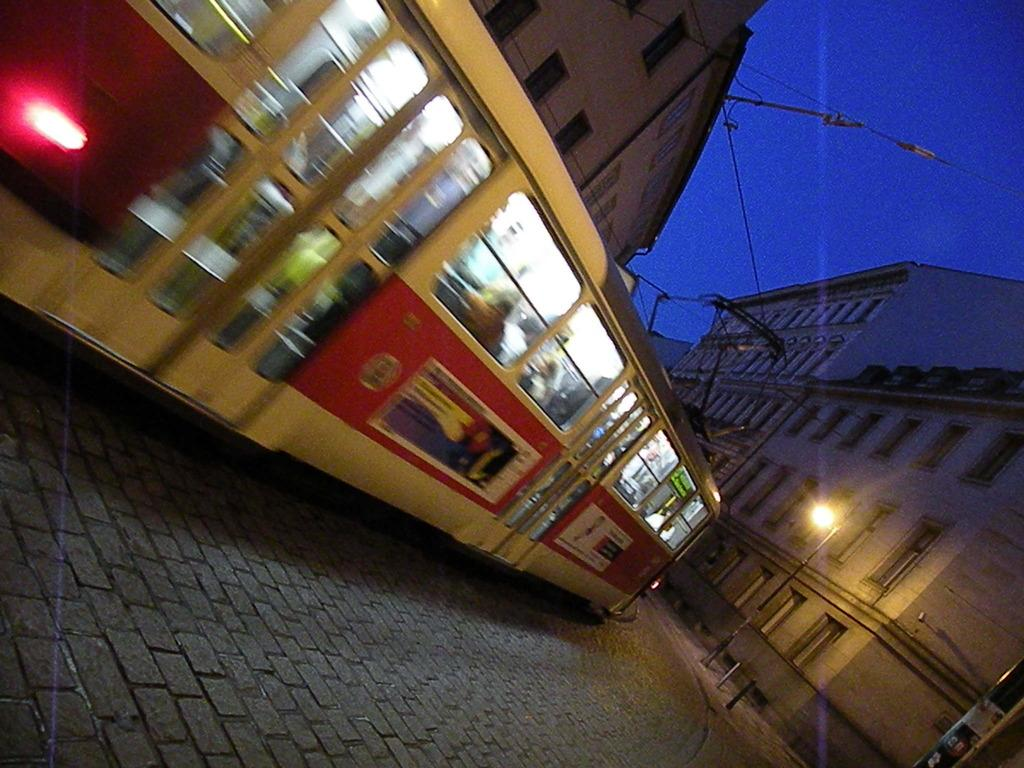What type of vehicle is in the image? There is a tram in the image. Who or what is inside the tram? There are people inside the tram. What can be seen in the background of the image? There are buildings visible in the image. What is the purpose of the pole in the image? The pole is likely used for support or to hold up the tram's wires. What is the function of the light in the image? The light might be used for illumination or signaling purposes. What else can be seen in the image related to the tram? There are wires in the image, which are likely used for powering the tram. What is visible in the sky in the image? The sky is visible in the image. How many toes can be seen on the people inside the tram? There is no way to determine the number of toes on the people inside the tram from the image. --- Facts: 1. There is a person holding a book in the image. 2. The book has a red cover. 3. The person is sitting on a chair. 4. There is a table in the image. 5. The table has a lamp on it. Absurd Topics: elephant, ocean, dance Conversation: What is the person in the image holding? The person is holding a book in the image. What color is the book's cover? The book has a red cover. Where is the person sitting? The person is sitting on a chair. What else can be seen in the image? There is a table in the image. What is on the table? The table has a lamp on it. Reasoning: Let's think step by step in order to produce the conversation. We start by identifying the main subject in the image, which is the person holding a book. Then, we expand the conversation to include other details about the book, such as its red cover. We also mention the person's location (sitting on a chair) and the presence of a table and a lamp. Each question is designed to elicit a specific detail about the image that is known from the provided facts. Absurd Question/Answer: Can you see an elephant swimming in the ocean in the image? No, there is no elephant or ocean present in the image. 